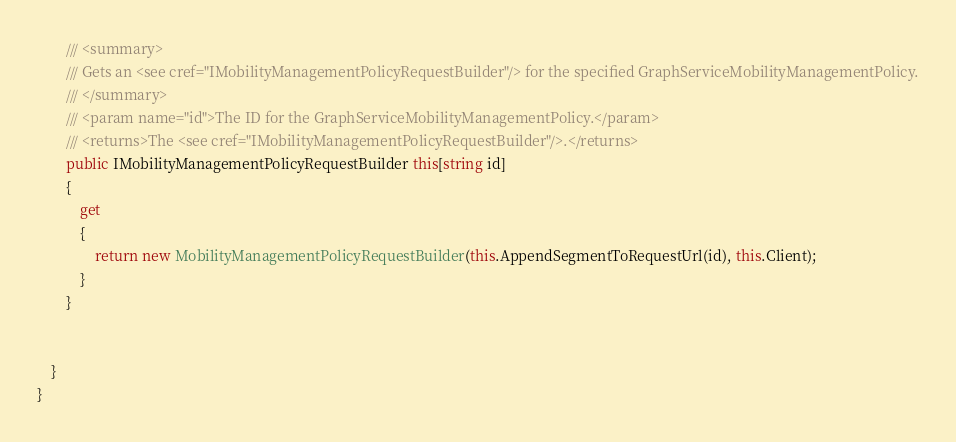Convert code to text. <code><loc_0><loc_0><loc_500><loc_500><_C#_>
        /// <summary>
        /// Gets an <see cref="IMobilityManagementPolicyRequestBuilder"/> for the specified GraphServiceMobilityManagementPolicy.
        /// </summary>
        /// <param name="id">The ID for the GraphServiceMobilityManagementPolicy.</param>
        /// <returns>The <see cref="IMobilityManagementPolicyRequestBuilder"/>.</returns>
        public IMobilityManagementPolicyRequestBuilder this[string id]
        {
            get
            {
                return new MobilityManagementPolicyRequestBuilder(this.AppendSegmentToRequestUrl(id), this.Client);
            }
        }

        
    }
}
</code> 